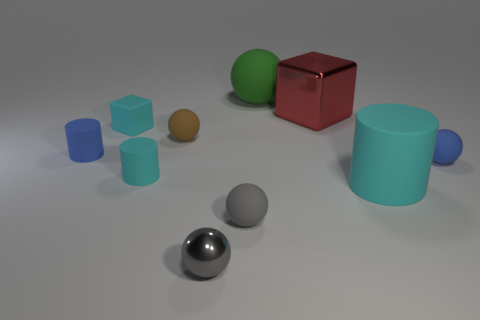Subtract all cylinders. How many objects are left? 7 Add 7 large cyan matte things. How many large cyan matte things are left? 8 Add 1 big cyan objects. How many big cyan objects exist? 2 Subtract 1 brown balls. How many objects are left? 9 Subtract all tiny cyan matte objects. Subtract all big red metallic blocks. How many objects are left? 7 